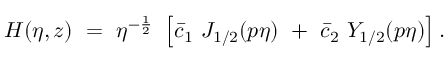Convert formula to latex. <formula><loc_0><loc_0><loc_500><loc_500>H ( \eta , z ) = \eta ^ { - \frac { 1 } { 2 } } \left [ \bar { c } _ { 1 } J _ { 1 / 2 } ( p \eta ) + \bar { c } _ { 2 } Y _ { 1 / 2 } ( p \eta ) \right ] .</formula> 